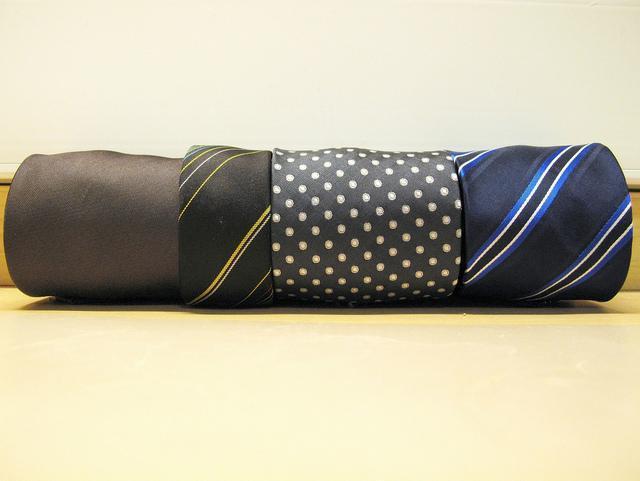How many ties are in the picture?
Give a very brief answer. 4. 